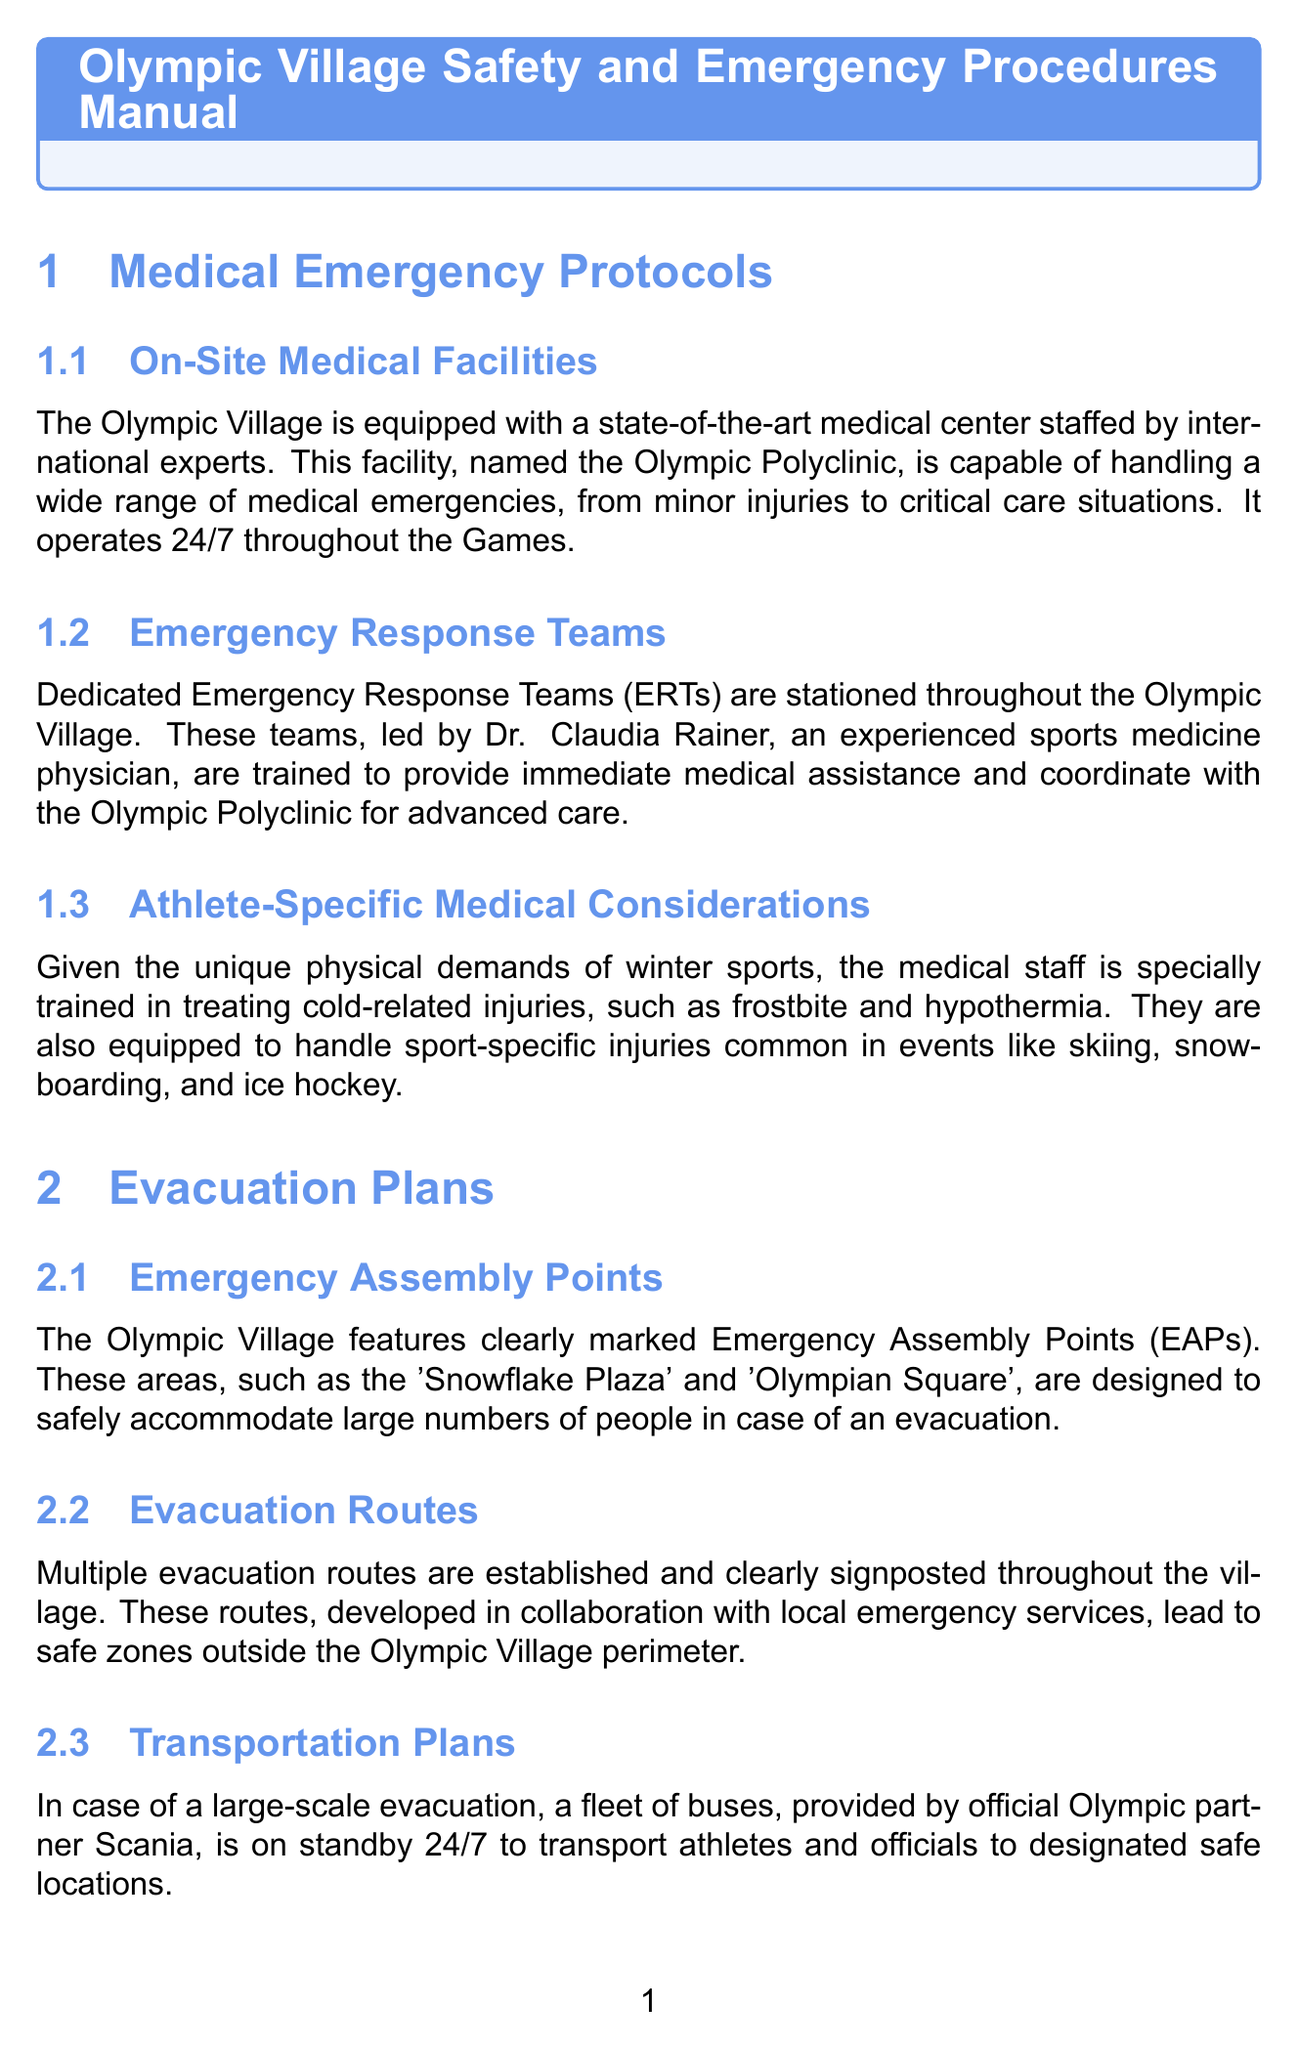What is the name of the on-site medical facility? The document states that the on-site medical facility is called the Olympic Polyclinic.
Answer: Olympic Polyclinic Who leads the Emergency Response Teams? The document mentions that the Emergency Response Teams are led by Dr. Claudia Rainer.
Answer: Dr. Claudia Rainer What type of communication system is used in emergencies? According to the document, a robust emergency communication system powered by Motorola Solutions is used.
Answer: Motorola Solutions How are emergency assembly points identified? The document specifies that the Olympic Village features clearly marked Emergency Assembly Points.
Answer: Clearly marked What transportation partner is on standby for evacuations? The document states that buses provided by official Olympic partner Scania are on standby.
Answer: Scania What precautions are taken for avalanche safety? The document mentions that regular risk assessments are conducted and avalanche barriers are installed in high-risk areas.
Answer: Regular risk assessments Which company manages ice and snow conditions? The document notes that a dedicated team from Swiss company Bächler Top Track is responsible for this.
Answer: Bächler Top Track How many areas are covered by the surveillance system? The document indicates that the surveillance system covers all areas of the Olympic Village.
Answer: All areas What language support is provided for emergency communications? The document emphasizes that emergency communications are provided in multiple languages.
Answer: Multiple languages 